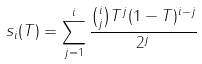Convert formula to latex. <formula><loc_0><loc_0><loc_500><loc_500>s _ { i } ( T ) = \sum _ { j = 1 } ^ { i } \frac { { i \choose j } T ^ { j } ( 1 - T ) ^ { i - j } } { 2 ^ { j } }</formula> 